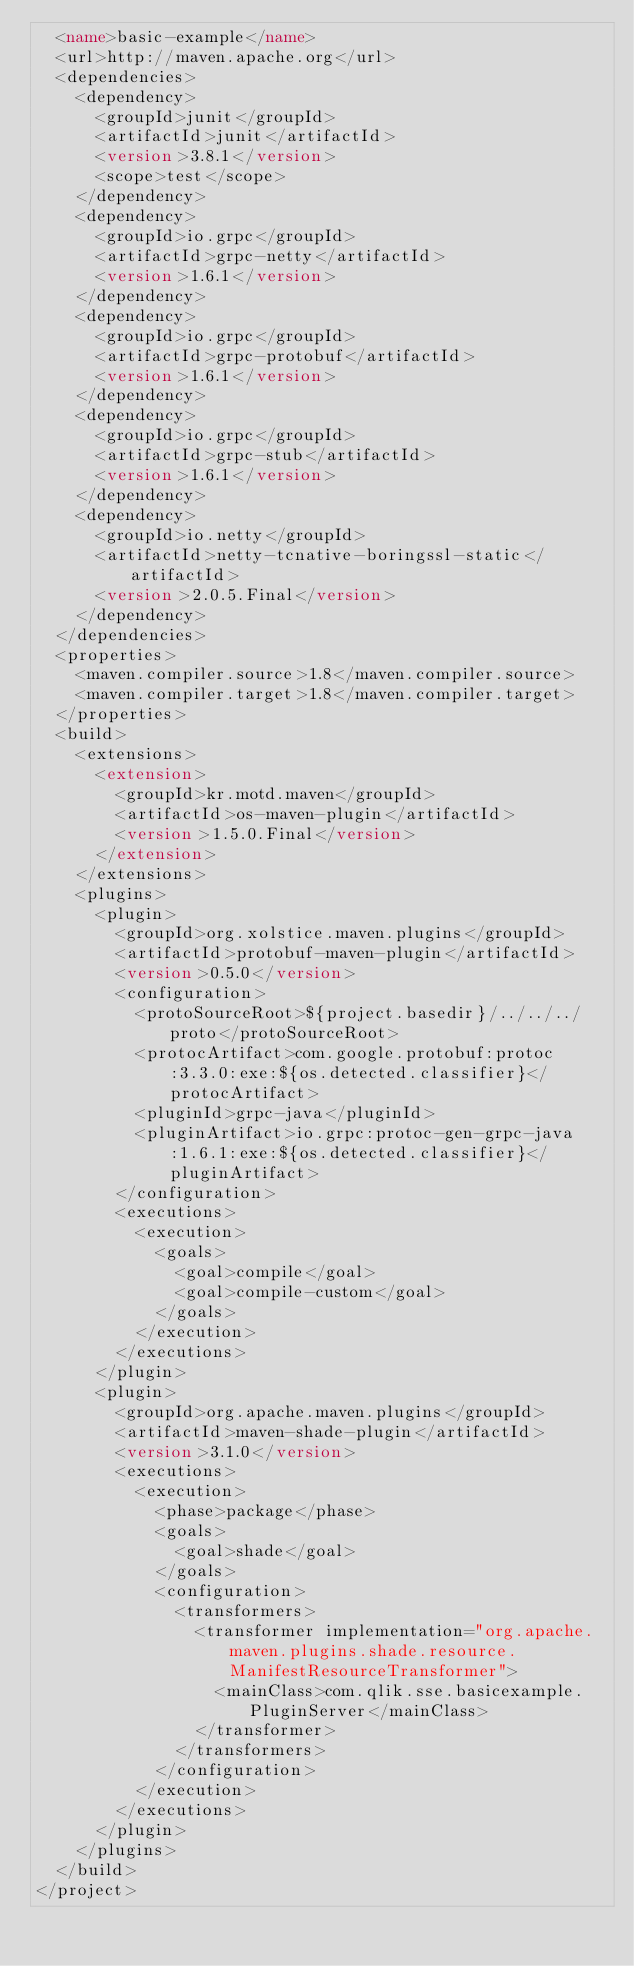<code> <loc_0><loc_0><loc_500><loc_500><_XML_>  <name>basic-example</name>
  <url>http://maven.apache.org</url>
  <dependencies>
    <dependency>
      <groupId>junit</groupId>
      <artifactId>junit</artifactId>
      <version>3.8.1</version>
      <scope>test</scope>
    </dependency>
    <dependency>
      <groupId>io.grpc</groupId>
      <artifactId>grpc-netty</artifactId>
      <version>1.6.1</version>
    </dependency>
    <dependency>
      <groupId>io.grpc</groupId>
      <artifactId>grpc-protobuf</artifactId>
      <version>1.6.1</version>
    </dependency>
    <dependency>
      <groupId>io.grpc</groupId>
      <artifactId>grpc-stub</artifactId>
      <version>1.6.1</version>
    </dependency>
    <dependency>
      <groupId>io.netty</groupId>
      <artifactId>netty-tcnative-boringssl-static</artifactId>
      <version>2.0.5.Final</version>
    </dependency>
  </dependencies>
  <properties>
    <maven.compiler.source>1.8</maven.compiler.source>
    <maven.compiler.target>1.8</maven.compiler.target>
  </properties>
  <build>
    <extensions>
      <extension>
        <groupId>kr.motd.maven</groupId>
        <artifactId>os-maven-plugin</artifactId>
        <version>1.5.0.Final</version>
      </extension>
    </extensions>
    <plugins>
      <plugin>
        <groupId>org.xolstice.maven.plugins</groupId>
        <artifactId>protobuf-maven-plugin</artifactId>
        <version>0.5.0</version>
        <configuration>
          <protoSourceRoot>${project.basedir}/../../../proto</protoSourceRoot>
          <protocArtifact>com.google.protobuf:protoc:3.3.0:exe:${os.detected.classifier}</protocArtifact>
          <pluginId>grpc-java</pluginId>
          <pluginArtifact>io.grpc:protoc-gen-grpc-java:1.6.1:exe:${os.detected.classifier}</pluginArtifact>
        </configuration>
        <executions>
          <execution>
            <goals>
              <goal>compile</goal>
              <goal>compile-custom</goal>
            </goals>
          </execution>
        </executions>
      </plugin>
      <plugin>
        <groupId>org.apache.maven.plugins</groupId>
        <artifactId>maven-shade-plugin</artifactId>
        <version>3.1.0</version>
        <executions>
          <execution>
            <phase>package</phase>
            <goals>
              <goal>shade</goal>
            </goals>
            <configuration>
              <transformers>
                <transformer implementation="org.apache.maven.plugins.shade.resource.ManifestResourceTransformer">
                  <mainClass>com.qlik.sse.basicexample.PluginServer</mainClass>
                </transformer>
              </transformers>
            </configuration>
          </execution>
        </executions>
      </plugin>
    </plugins>
  </build>
</project>
</code> 